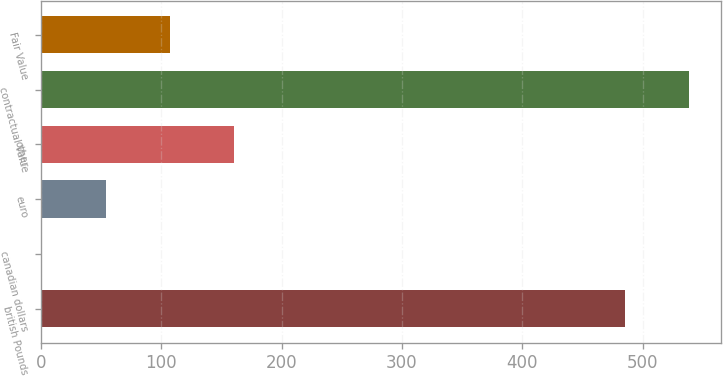<chart> <loc_0><loc_0><loc_500><loc_500><bar_chart><fcel>british Pounds<fcel>canadian dollars<fcel>euro<fcel>other<fcel>contractual Value<fcel>Fair Value<nl><fcel>485.6<fcel>1.2<fcel>54.18<fcel>160.14<fcel>538.58<fcel>107.16<nl></chart> 